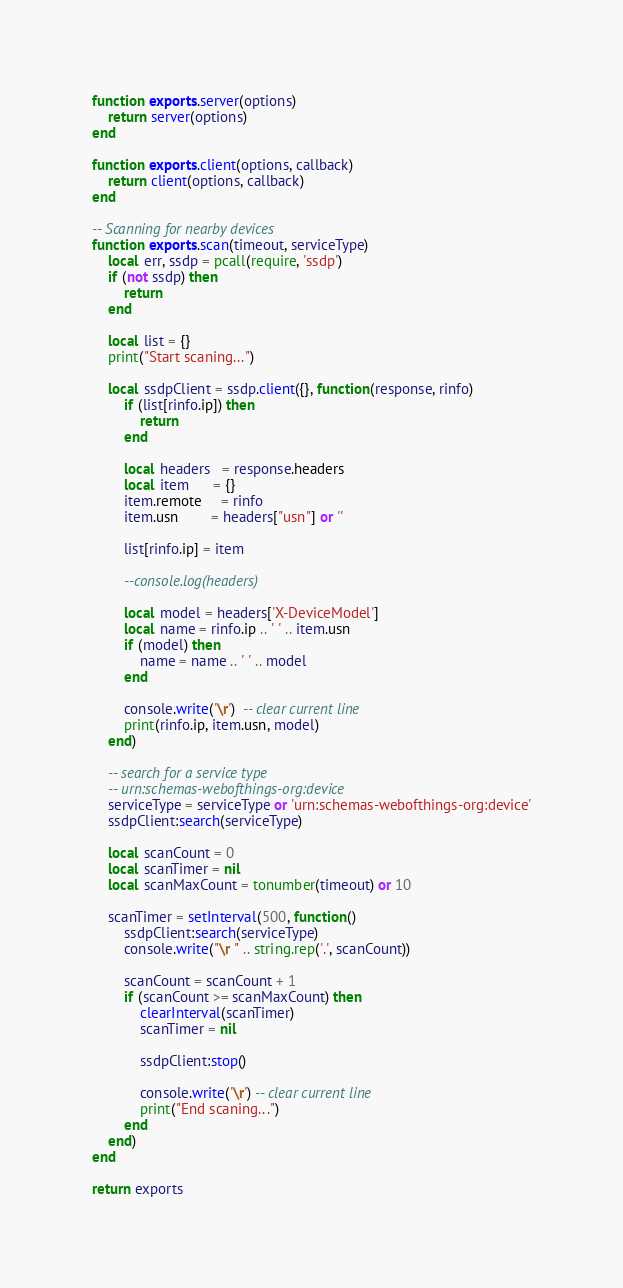<code> <loc_0><loc_0><loc_500><loc_500><_Lua_>
function exports.server(options)
    return server(options)
end

function exports.client(options, callback)
    return client(options, callback)
end

-- Scanning for nearby devices
function exports.scan(timeout, serviceType)
	local err, ssdp = pcall(require, 'ssdp')
	if (not ssdp) then
		return
	end

	local list = {}
	print("Start scaning...")

	local ssdpClient = ssdp.client({}, function(response, rinfo)
		if (list[rinfo.ip]) then
			return
		end

		local headers   = response.headers
		local item      = {}
		item.remote     = rinfo
		item.usn        = headers["usn"] or ''

		list[rinfo.ip] = item

		--console.log(headers)

		local model = headers['X-DeviceModel']
		local name = rinfo.ip .. ' ' .. item.usn
		if (model) then
			name = name .. ' ' .. model
		end

		console.write('\r')  -- clear current line
		print(rinfo.ip, item.usn, model)
	end)

	-- search for a service type
	-- urn:schemas-webofthings-org:device
	serviceType = serviceType or 'urn:schemas-webofthings-org:device'
	ssdpClient:search(serviceType)

	local scanCount = 0
	local scanTimer = nil
	local scanMaxCount = tonumber(timeout) or 10

	scanTimer = setInterval(500, function()
		ssdpClient:search(serviceType)
		console.write("\r " .. string.rep('.', scanCount))

		scanCount = scanCount + 1
		if (scanCount >= scanMaxCount) then
			clearInterval(scanTimer)
			scanTimer = nil

			ssdpClient:stop()

			console.write('\r') -- clear current line
			print("End scaning...")
		end
	end)
end

return exports</code> 